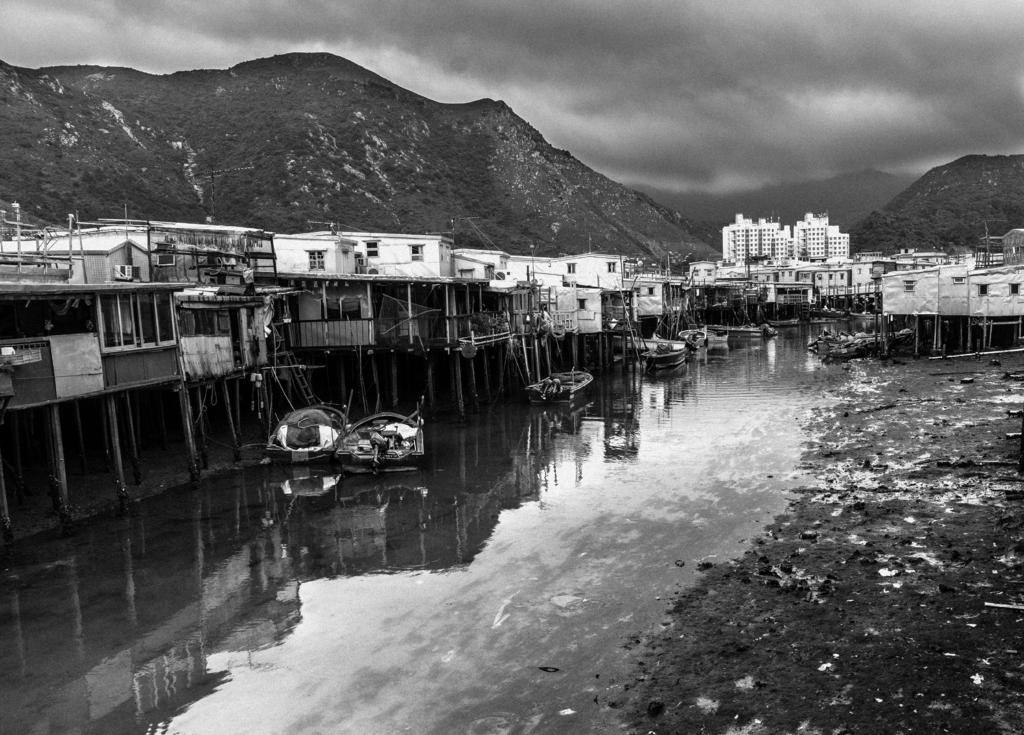What is the primary element in the image? There is water in the image. What is floating on the water? There are boats on the water. What structures can be seen in the image? There are buildings visible in the image. What type of landscape is visible in the background of the image? There are mountains in the background of the image. How would you describe the weather in the image? The sky is cloudy in the background of the image. What type of mask is being worn by the person in the image? There is no person present in the image, and therefore no mask can be observed. What type of prose is being written on the boats in the image? There is no writing or prose present on the boats in the image. 